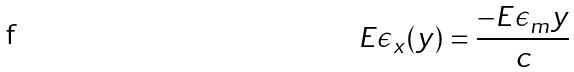<formula> <loc_0><loc_0><loc_500><loc_500>E \epsilon _ { x } ( y ) = \frac { - E \epsilon _ { m } y } { c }</formula> 